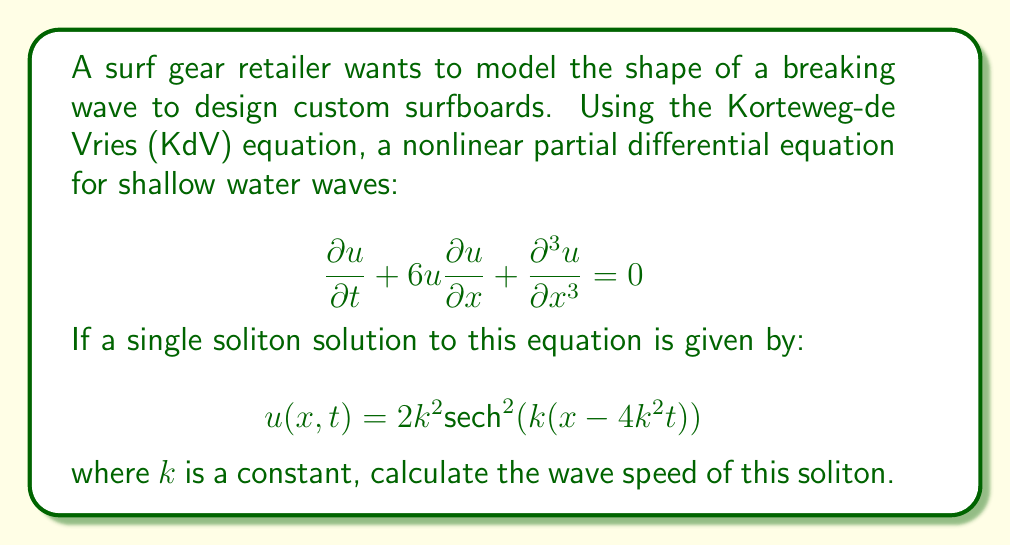Provide a solution to this math problem. To find the wave speed of the soliton, we need to analyze the solution:

$$u(x,t) = 2k^2 \text{sech}^2(k(x-4k^2t))$$

1) The soliton maintains its shape as it moves. Its peak follows the path where the argument of sech² is zero:

   $$k(x-4k^2t) = 0$$

2) Solving this equation for x:

   $$x = 4k^2t$$

3) The position of the peak, x, is changing with time, t. The rate of this change gives us the wave speed:

   $$\text{Wave Speed} = \frac{dx}{dt} = \frac{d}{dt}(4k^2t) = 4k^2$$

Thus, the wave speed of the soliton is $4k^2$.

This result shows that for the KdV equation, larger amplitude waves (larger $k$) travel faster, which is a characteristic feature of nonlinear wave equations.
Answer: $4k^2$ 